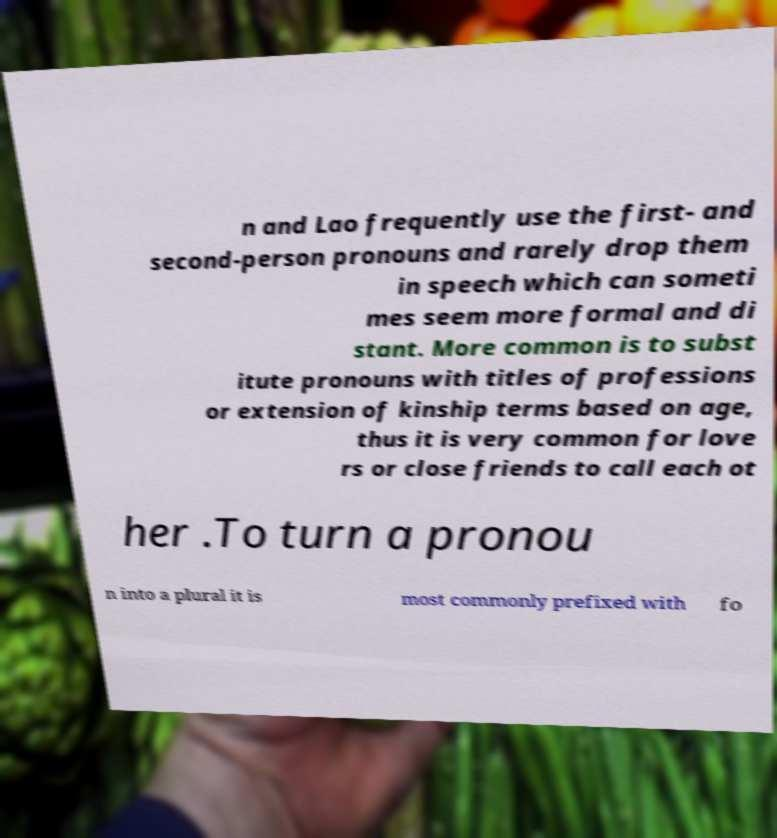What messages or text are displayed in this image? I need them in a readable, typed format. n and Lao frequently use the first- and second-person pronouns and rarely drop them in speech which can someti mes seem more formal and di stant. More common is to subst itute pronouns with titles of professions or extension of kinship terms based on age, thus it is very common for love rs or close friends to call each ot her .To turn a pronou n into a plural it is most commonly prefixed with fo 